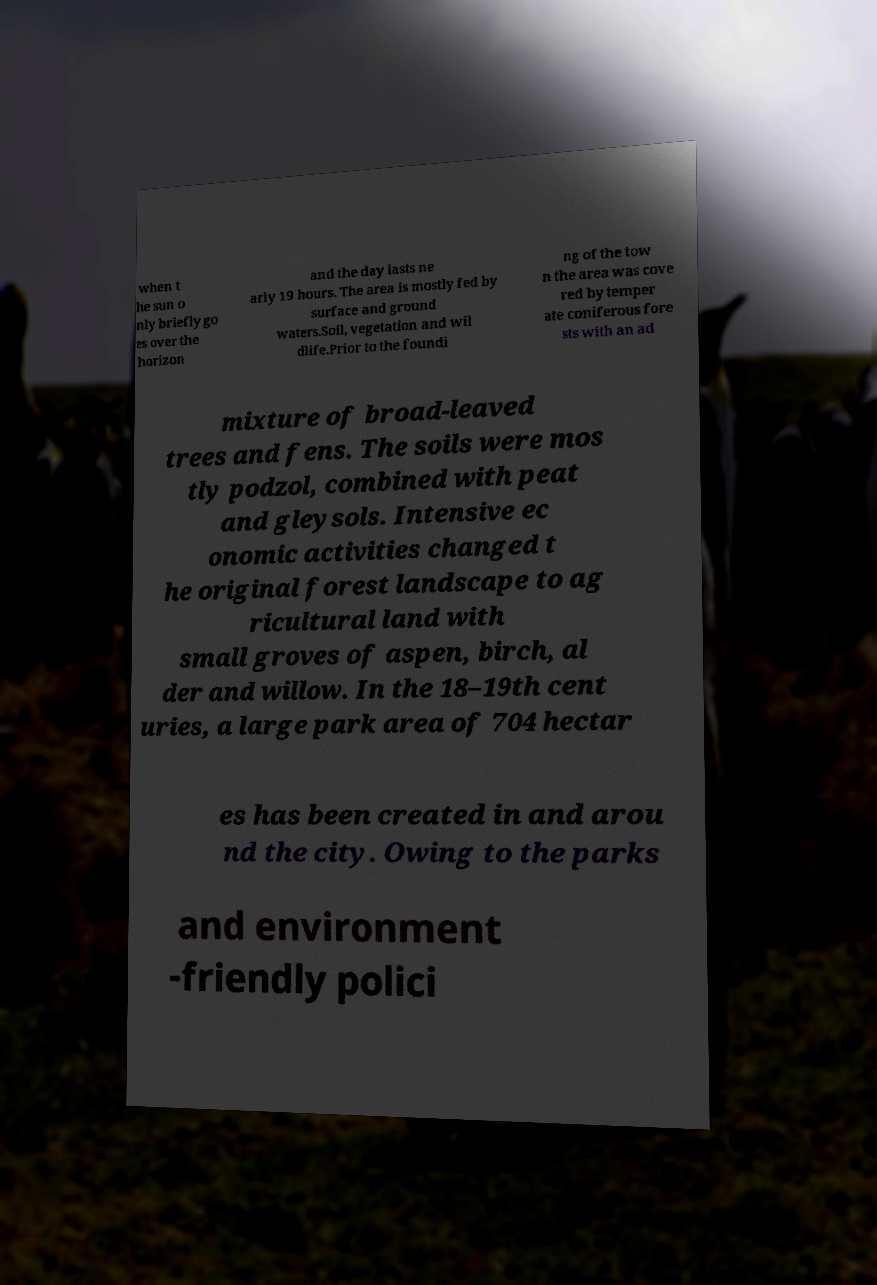Please identify and transcribe the text found in this image. when t he sun o nly briefly go es over the horizon and the day lasts ne arly 19 hours. The area is mostly fed by surface and ground waters.Soil, vegetation and wil dlife.Prior to the foundi ng of the tow n the area was cove red by temper ate coniferous fore sts with an ad mixture of broad-leaved trees and fens. The soils were mos tly podzol, combined with peat and gleysols. Intensive ec onomic activities changed t he original forest landscape to ag ricultural land with small groves of aspen, birch, al der and willow. In the 18–19th cent uries, a large park area of 704 hectar es has been created in and arou nd the city. Owing to the parks and environment -friendly polici 